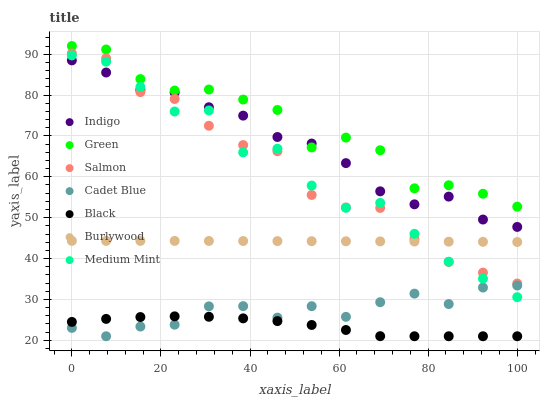Does Black have the minimum area under the curve?
Answer yes or no. Yes. Does Green have the maximum area under the curve?
Answer yes or no. Yes. Does Cadet Blue have the minimum area under the curve?
Answer yes or no. No. Does Cadet Blue have the maximum area under the curve?
Answer yes or no. No. Is Burlywood the smoothest?
Answer yes or no. Yes. Is Medium Mint the roughest?
Answer yes or no. Yes. Is Cadet Blue the smoothest?
Answer yes or no. No. Is Cadet Blue the roughest?
Answer yes or no. No. Does Cadet Blue have the lowest value?
Answer yes or no. Yes. Does Indigo have the lowest value?
Answer yes or no. No. Does Green have the highest value?
Answer yes or no. Yes. Does Cadet Blue have the highest value?
Answer yes or no. No. Is Cadet Blue less than Salmon?
Answer yes or no. Yes. Is Green greater than Burlywood?
Answer yes or no. Yes. Does Burlywood intersect Medium Mint?
Answer yes or no. Yes. Is Burlywood less than Medium Mint?
Answer yes or no. No. Is Burlywood greater than Medium Mint?
Answer yes or no. No. Does Cadet Blue intersect Salmon?
Answer yes or no. No. 